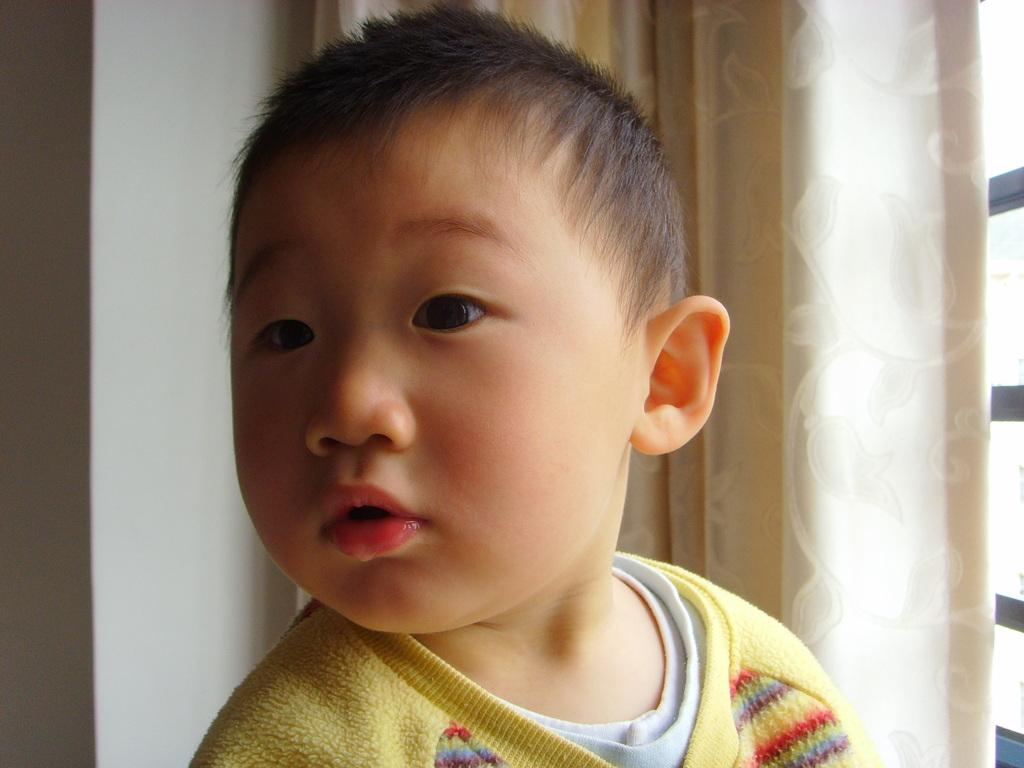Who is present in the image? There is a boy in the image. What is the boy wearing? The boy is wearing a yellow sweater. What can be seen hanging in the image? There is a curtain hanging in the image. Where is the window located in the image? There is a window on the right side of the image. What type of structure is visible in the image? There is a wall visible in the image. What type of clover can be seen growing on the wall in the image? There is no clover present in the image; it is a wall without any plants. How does the boy maintain a quiet demeanor in the image? The image does not provide information about the boy's demeanor or noise level. 